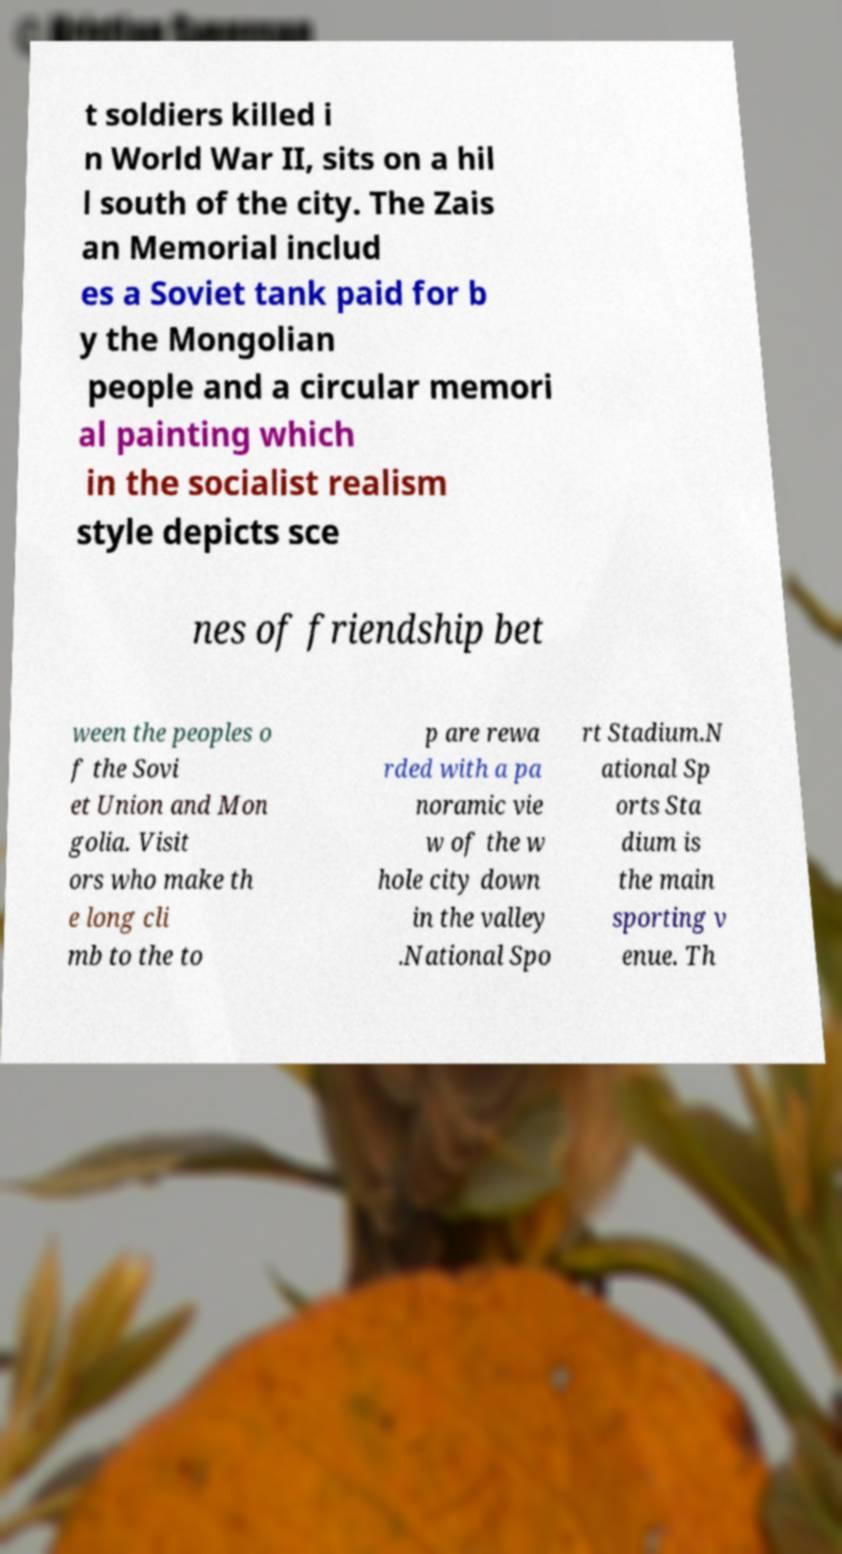Could you extract and type out the text from this image? t soldiers killed i n World War II, sits on a hil l south of the city. The Zais an Memorial includ es a Soviet tank paid for b y the Mongolian people and a circular memori al painting which in the socialist realism style depicts sce nes of friendship bet ween the peoples o f the Sovi et Union and Mon golia. Visit ors who make th e long cli mb to the to p are rewa rded with a pa noramic vie w of the w hole city down in the valley .National Spo rt Stadium.N ational Sp orts Sta dium is the main sporting v enue. Th 